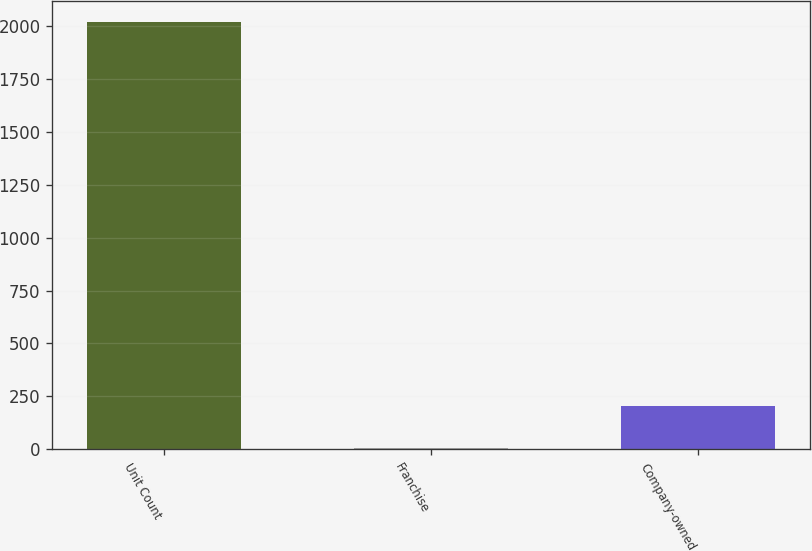Convert chart to OTSL. <chart><loc_0><loc_0><loc_500><loc_500><bar_chart><fcel>Unit Count<fcel>Franchise<fcel>Company-owned<nl><fcel>2017<fcel>5<fcel>206.2<nl></chart> 